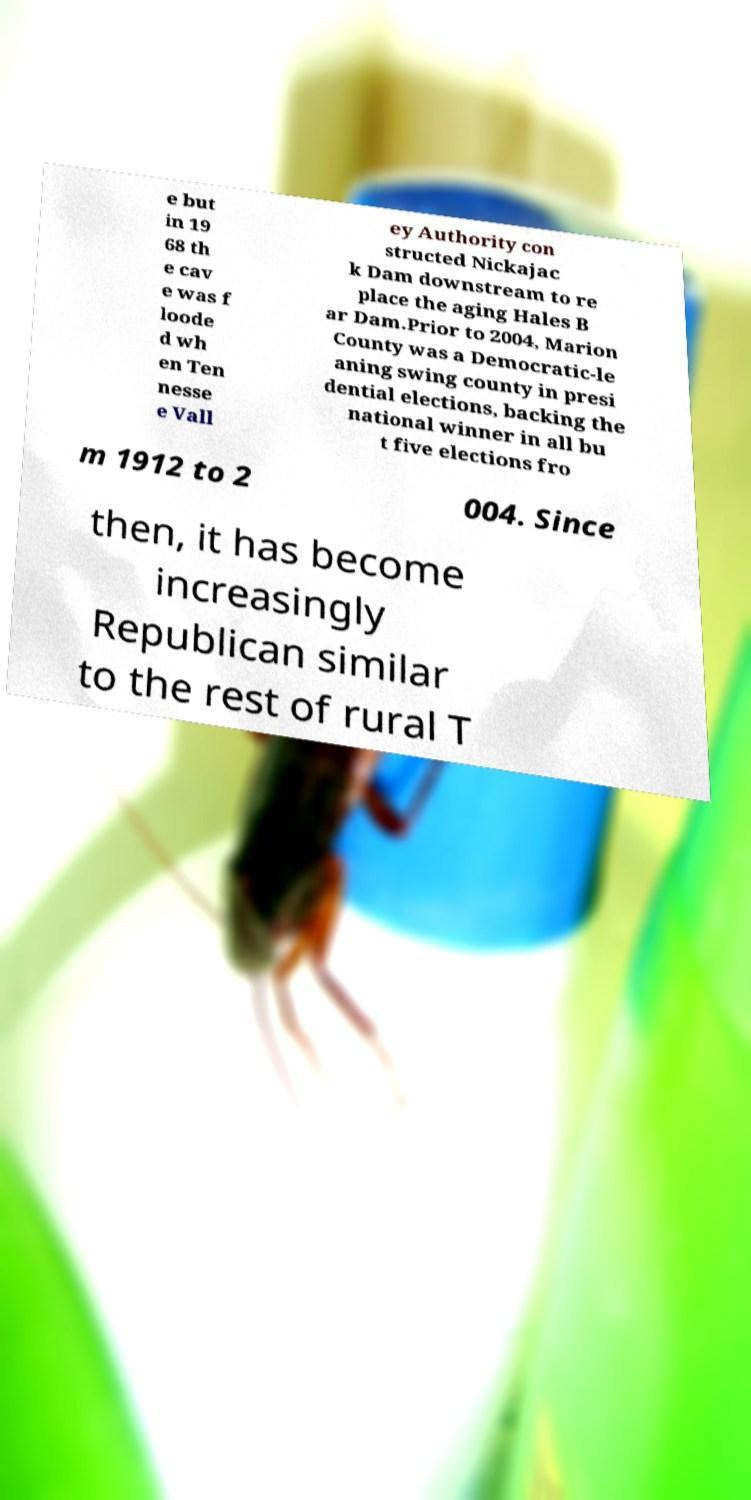Please read and relay the text visible in this image. What does it say? e but in 19 68 th e cav e was f loode d wh en Ten nesse e Vall ey Authority con structed Nickajac k Dam downstream to re place the aging Hales B ar Dam.Prior to 2004, Marion County was a Democratic-le aning swing county in presi dential elections, backing the national winner in all bu t five elections fro m 1912 to 2 004. Since then, it has become increasingly Republican similar to the rest of rural T 